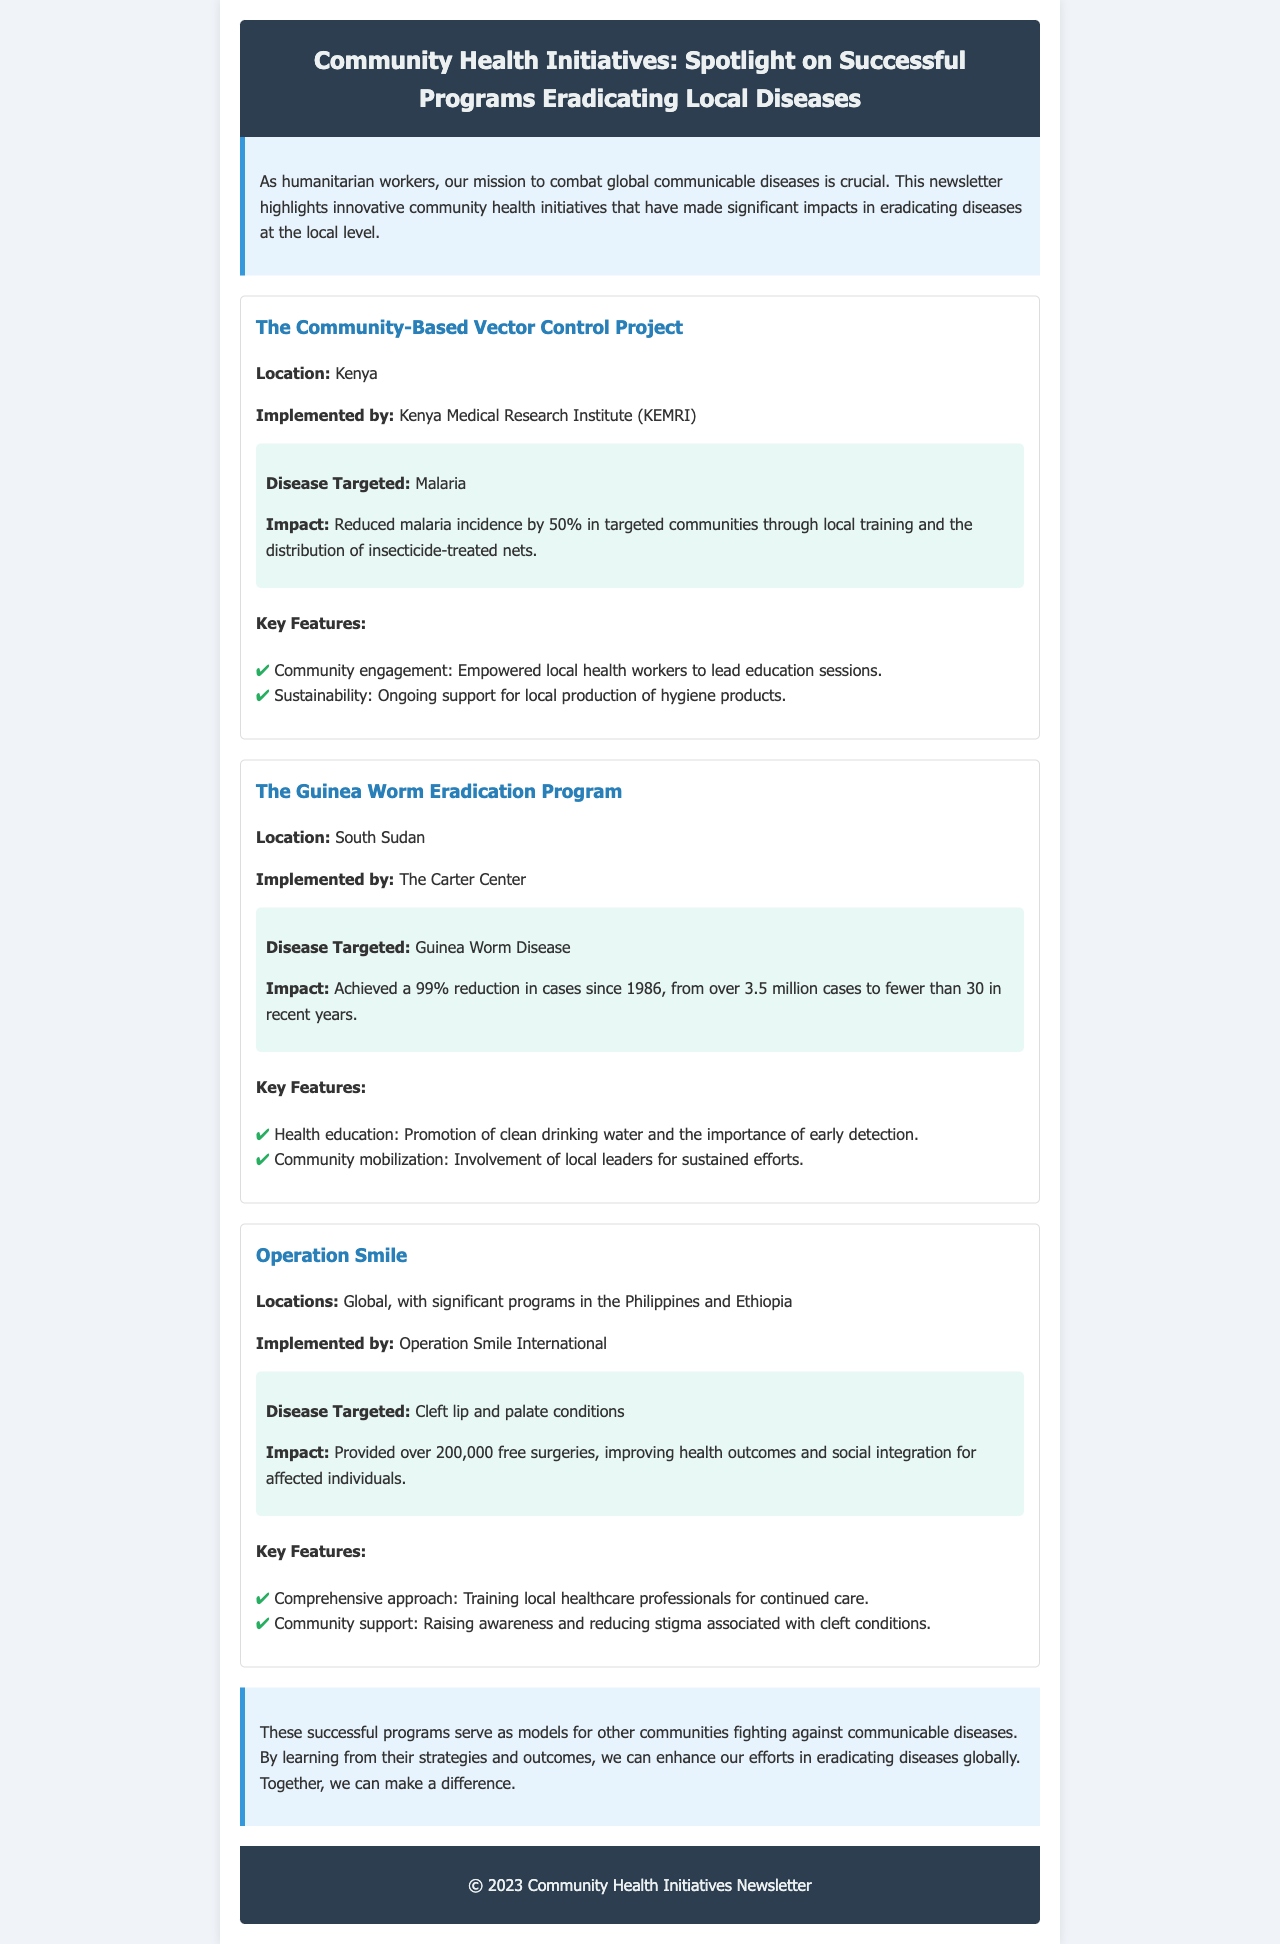What is the title of the newsletter? The title of the newsletter is prominently displayed in the header section.
Answer: Community Health Initiatives: Spotlight on Successful Programs Eradicating Local Diseases Which disease did the Community-Based Vector Control Project target? The specific disease targeted by the Community-Based Vector Control Project is mentioned in its description.
Answer: Malaria What percentage reduction in Guinea Worm Disease cases has been achieved since 1986? This percentage is highlighted in the success story of the Guinea Worm Eradication Program.
Answer: 99% What organization implemented the Operation Smile program? The implementing organization is specified in the success story of the Operation Smile initiative.
Answer: Operation Smile International What is a key feature of the Guinea Worm Eradication Program? The key features are listed under each success story, focusing on the strategies employed.
Answer: Health education: Promotion of clean drinking water and the importance of early detection How many free surgeries has Operation Smile provided? The total number of surgeries performed is mentioned in the impact section of the Operation Smile story.
Answer: Over 200,000 What is the location of the Community-Based Vector Control Project? The location is provided at the beginning of each success story.
Answer: Kenya What is a common theme among the successful programs highlighted in the newsletter? The conclusion summarizes the overall theme and intended lessons from the programs.
Answer: Models for other communities fighting against communicable diseases 